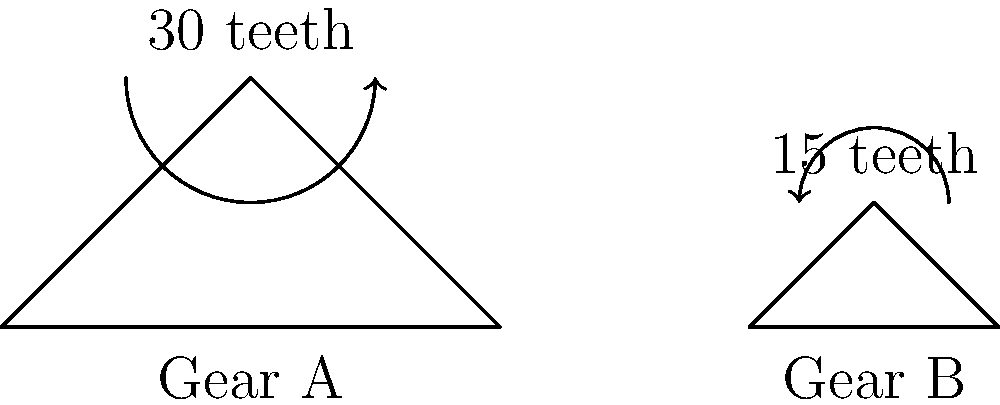In our senior social club's latest project, we're building a simple machine with two gears. Gear A has 30 teeth and Gear B has 15 teeth. If Gear A makes one complete revolution, how many revolutions will Gear B make? Explain your reasoning, considering how this gear configuration might be used in everyday objects we seniors often encounter. Let's approach this step-by-step, thinking about how gears work in devices we often use, like analog clocks or hand-operated can openers:

1) First, we need to understand the relationship between the number of teeth and gear rotations:
   - The number of teeth that mesh between two gears must be equal for one complete cycle.

2) For one complete revolution of Gear A:
   - Gear A will rotate all 30 of its teeth.
   - These 30 teeth must mesh with Gear B.

3) Now, let's consider Gear B:
   - Gear B only has 15 teeth.
   - To mesh with all 30 teeth from Gear A, Gear B must rotate twice.

4) We can express this mathematically:
   $$\frac{\text{Teeth in Gear A}}{\text{Teeth in Gear B}} = \frac{30}{15} = 2$$

5) This ratio of 2 means that for every 1 revolution of Gear A, Gear B will make 2 revolutions.

This principle is used in many devices we encounter. For example, in a manual egg beater, this gear ratio would allow the beaters to spin faster than the hand crank, making whisking more efficient.
Answer: 2 revolutions 